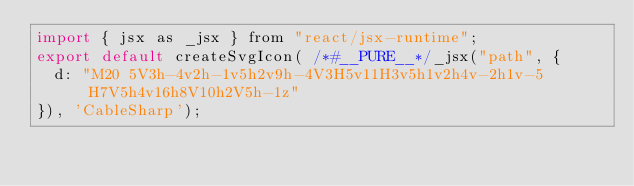<code> <loc_0><loc_0><loc_500><loc_500><_JavaScript_>import { jsx as _jsx } from "react/jsx-runtime";
export default createSvgIcon( /*#__PURE__*/_jsx("path", {
  d: "M20 5V3h-4v2h-1v5h2v9h-4V3H5v11H3v5h1v2h4v-2h1v-5H7V5h4v16h8V10h2V5h-1z"
}), 'CableSharp');</code> 